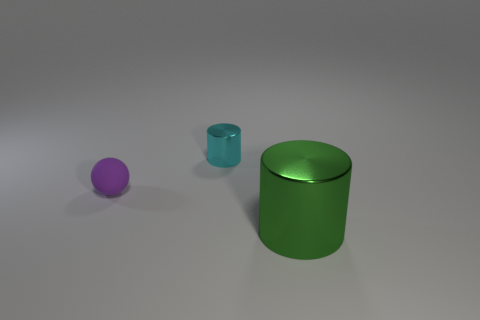Do the cyan metal cylinder and the green cylinder have the same size?
Keep it short and to the point. No. How many small cylinders are the same material as the big cylinder?
Your answer should be compact. 1. There is a green thing that is the same shape as the cyan shiny object; what size is it?
Make the answer very short. Large. There is a small thing on the right side of the purple sphere; is it the same shape as the green object?
Your answer should be very brief. Yes. There is a small rubber object left of the thing that is in front of the small purple ball; what shape is it?
Give a very brief answer. Sphere. Is there anything else that is the same shape as the small purple rubber object?
Provide a succinct answer. No. There is another small thing that is the same shape as the green metallic object; what color is it?
Offer a terse response. Cyan. The object that is both in front of the small metal thing and on the left side of the big green metallic thing has what shape?
Your answer should be very brief. Sphere. Is the number of small purple rubber balls less than the number of large gray metallic cylinders?
Your answer should be very brief. No. Are any cyan things visible?
Your response must be concise. Yes. 